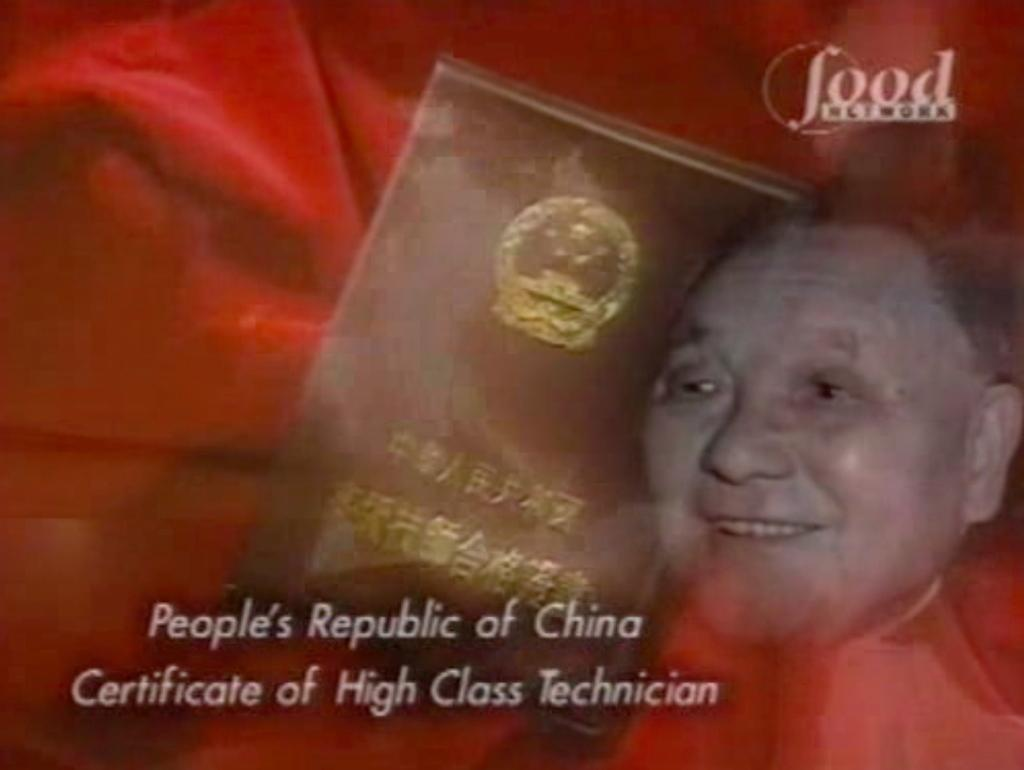What type of image is this? The image is an edited version. What can be seen on the person's face in the image? There is a person's face in the image, but no specific details about the face are mentioned. What object is present in the image related to identification? There is a passport in the image. What is the nature of the text in the image? There is some text in the image, but no specific details about the text are mentioned. What type of crack is visible on the island in the image? There is no island present in the image, so there cannot be a crack on it. What type of maid is shown in the image? There is no maid present in the image. 